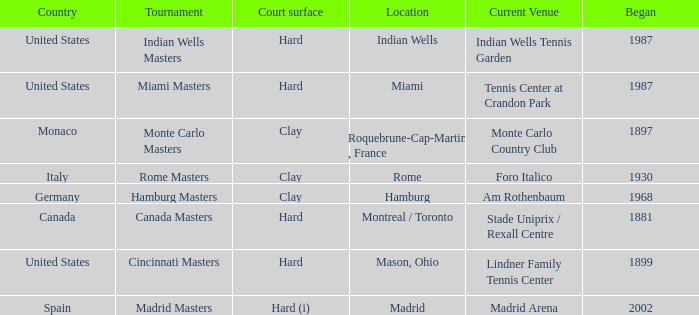Which current venues location is Mason, Ohio? Lindner Family Tennis Center. 